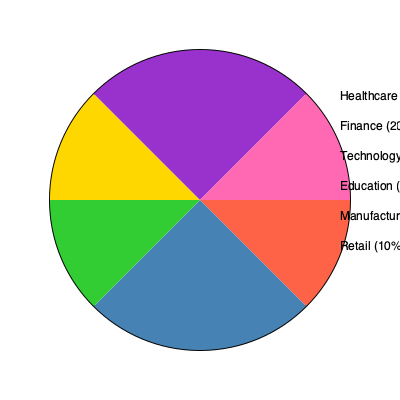Based on the pie chart showing the distribution of job sectors in Chicago, which sector has the largest share of employment, and what percentage does it represent? To answer this question, we need to analyze the pie chart and the accompanying legend:

1. The pie chart is divided into six sectors, each representing a different job sector in Chicago.
2. Each sector is color-coded and labeled with its corresponding percentage in the legend.
3. The sectors and their percentages are:
   - Healthcare: 25%
   - Finance: 20%
   - Technology: 15%
   - Education: 15%
   - Manufacturing: 15%
   - Retail: 10%
4. To find the largest share, we need to compare these percentages.
5. The largest percentage among all sectors is 25%, which corresponds to the Healthcare sector.

Therefore, the sector with the largest share of employment in Chicago is Healthcare, representing 25% of the job market.
Answer: Healthcare, 25% 